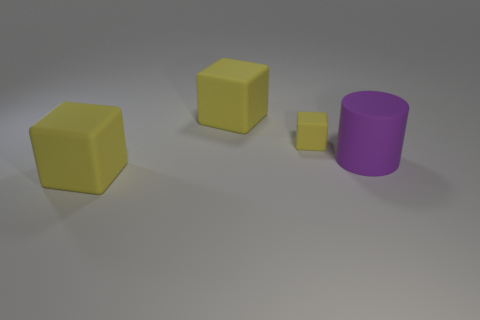There is another tiny thing that is the same material as the purple object; what color is it?
Offer a very short reply. Yellow. Is the color of the big thing behind the tiny yellow cube the same as the matte block in front of the big purple object?
Your response must be concise. Yes. Are there more yellow matte things that are on the left side of the tiny yellow matte cube than large objects right of the purple matte thing?
Ensure brevity in your answer.  Yes. Are there any other things that are the same shape as the large purple rubber object?
Provide a succinct answer. No. There is a purple matte thing; is it the same shape as the big yellow object in front of the big purple object?
Your answer should be very brief. No. What number of other things are there of the same material as the purple cylinder
Make the answer very short. 3. Do the large rubber cylinder and the big thing that is in front of the cylinder have the same color?
Your answer should be compact. No. There is a big block that is behind the tiny block; what is its material?
Your response must be concise. Rubber. Are there any other cylinders that have the same color as the cylinder?
Provide a short and direct response. No. What number of tiny objects are either purple cylinders or yellow objects?
Ensure brevity in your answer.  1. 